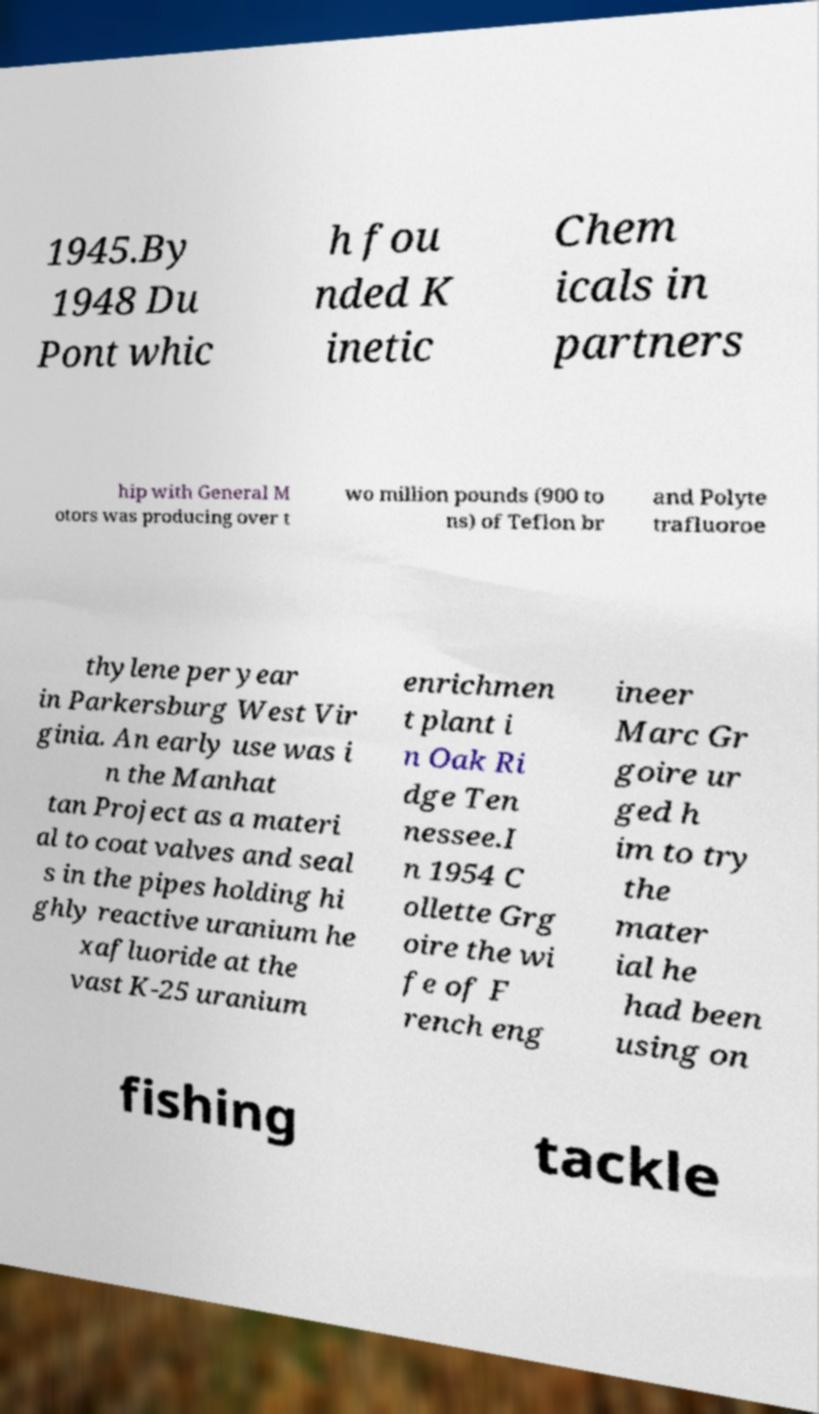Can you read and provide the text displayed in the image?This photo seems to have some interesting text. Can you extract and type it out for me? 1945.By 1948 Du Pont whic h fou nded K inetic Chem icals in partners hip with General M otors was producing over t wo million pounds (900 to ns) of Teflon br and Polyte trafluoroe thylene per year in Parkersburg West Vir ginia. An early use was i n the Manhat tan Project as a materi al to coat valves and seal s in the pipes holding hi ghly reactive uranium he xafluoride at the vast K-25 uranium enrichmen t plant i n Oak Ri dge Ten nessee.I n 1954 C ollette Grg oire the wi fe of F rench eng ineer Marc Gr goire ur ged h im to try the mater ial he had been using on fishing tackle 